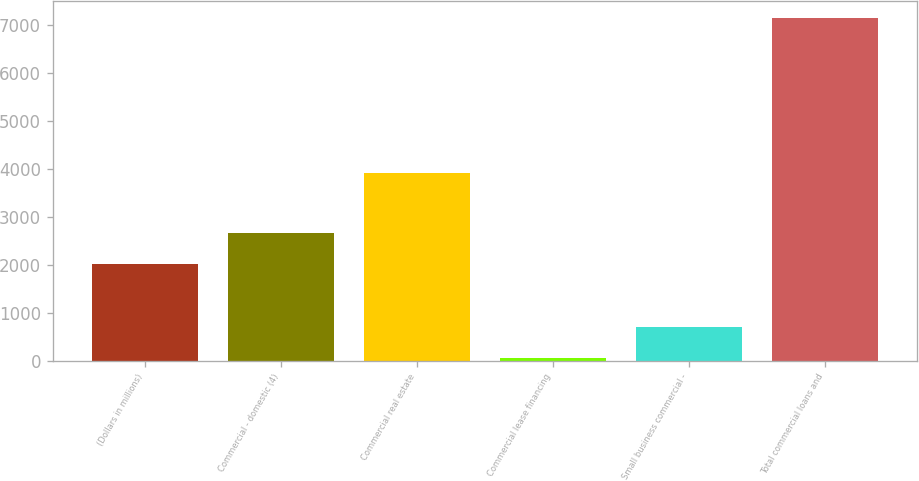Convert chart. <chart><loc_0><loc_0><loc_500><loc_500><bar_chart><fcel>(Dollars in millions)<fcel>Commercial - domestic (4)<fcel>Commercial real estate<fcel>Commercial lease financing<fcel>Small business commercial -<fcel>Total commercial loans and<nl><fcel>2008<fcel>2652.1<fcel>3906<fcel>56<fcel>700.1<fcel>7141.1<nl></chart> 